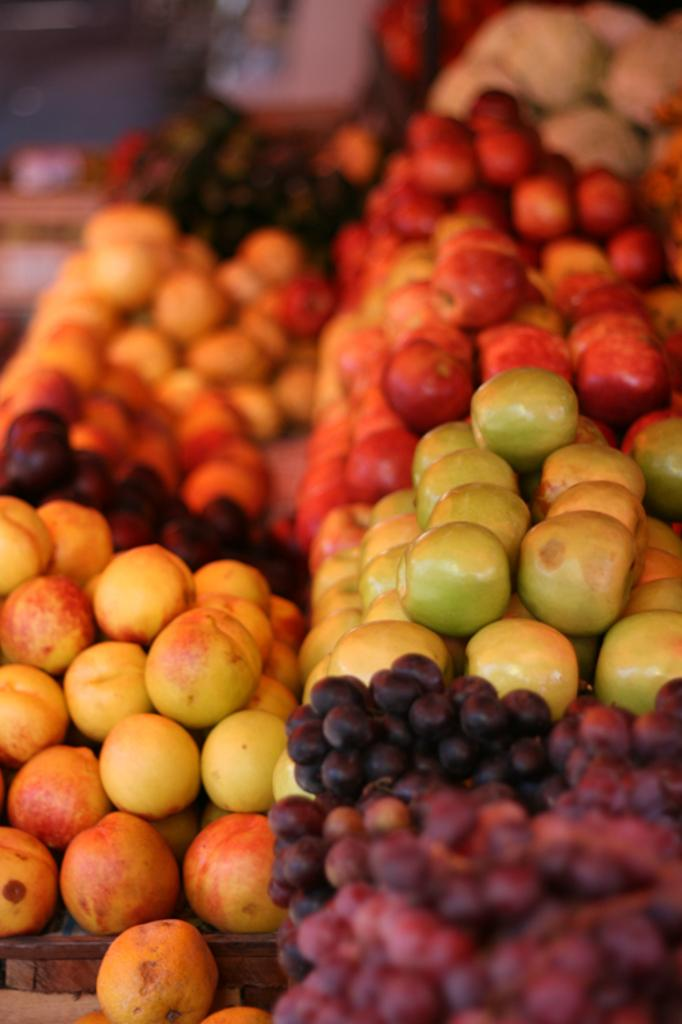What type of fruit can be seen in the image? There are apples and grapes in the image. Can you describe the background of the image? The background of the image is blurred. What type of cannon is being used by the uncle in the image? There is no uncle or cannon present in the image. What is the arm doing in the image? There is no arm visible in the image. 